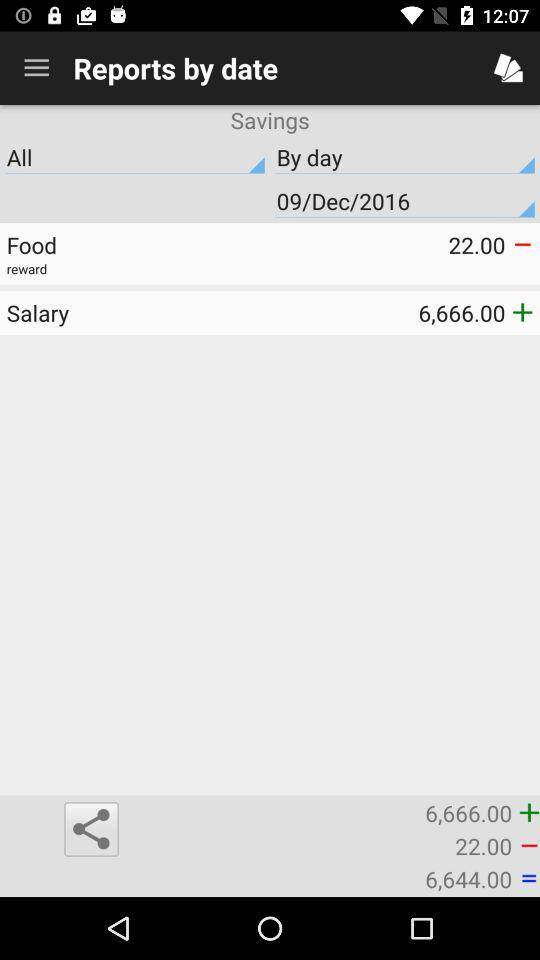How much is the food expense? The food expense is 22. 